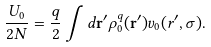Convert formula to latex. <formula><loc_0><loc_0><loc_500><loc_500>\frac { U _ { 0 } } { 2 N } = \frac { q } { 2 } \int d { \mathbf r ^ { \prime } } \rho ^ { q } _ { 0 } ( { \mathbf r ^ { \prime } } ) v _ { 0 } ( r ^ { \prime } , \sigma ) .</formula> 